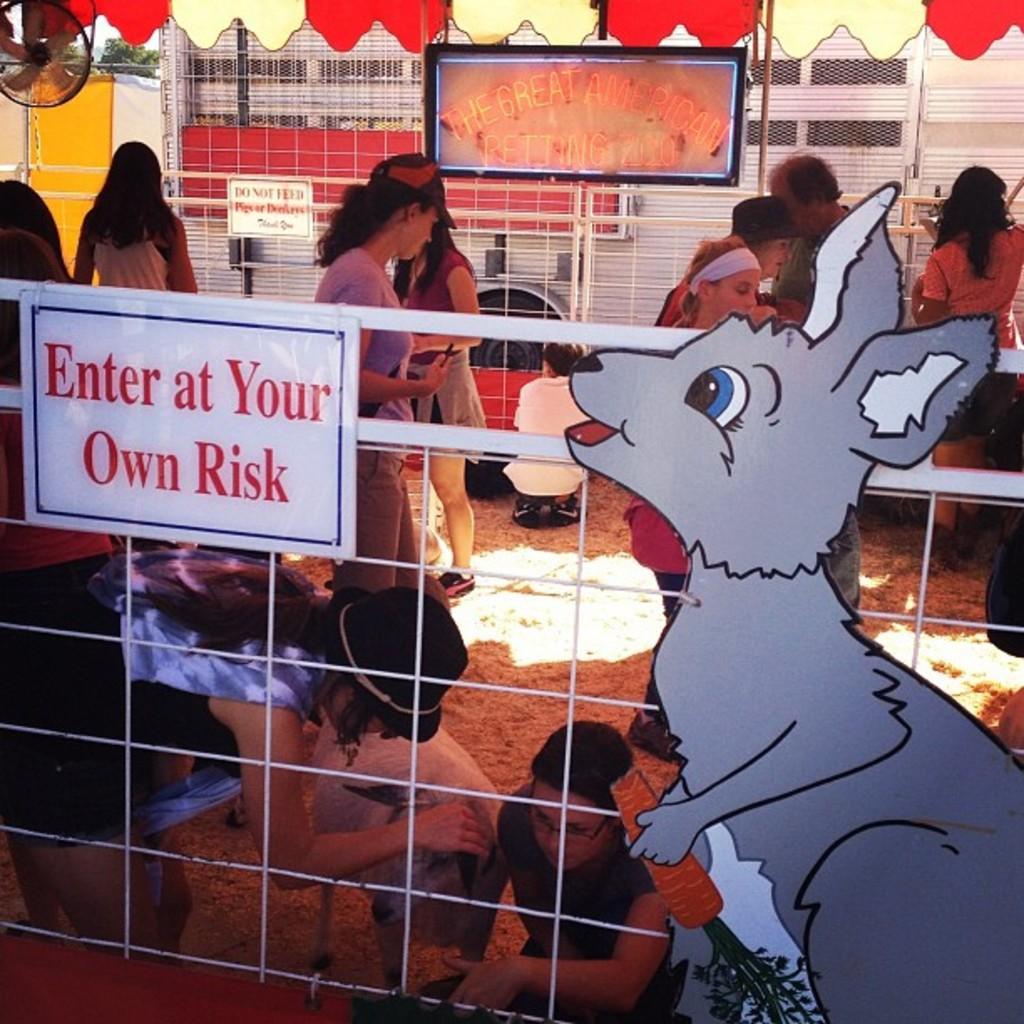How would you summarize this image in a sentence or two? In this picture we can see a fence with a board and behind the fence there are groups of people and an animal. Behind the people there is a board and a wall. 